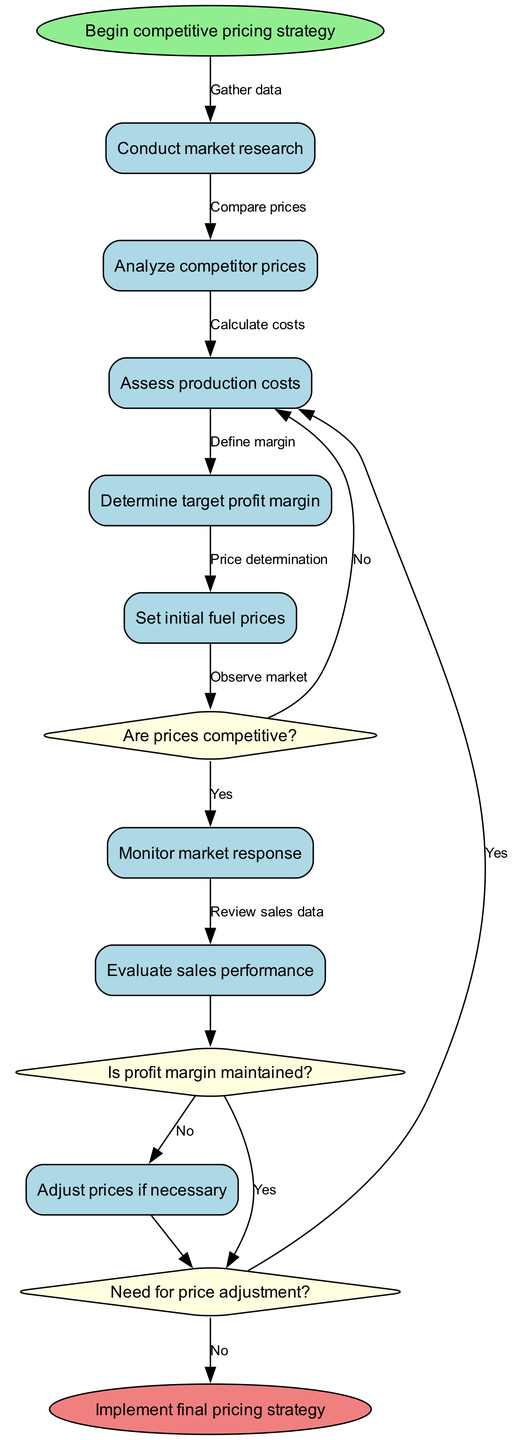What's the starting activity in this diagram? The diagram begins with the "Begin competitive pricing strategy" node, which is indicated as the start node.
Answer: Begin competitive pricing strategy How many activities are there in the diagram? The diagram lists a total of eight activities that describe the steps in implementing the pricing strategy.
Answer: Eight What is the first decision node in the diagram? The first decision node is "Are prices competitive?", which comes after setting the initial fuel prices.
Answer: Are prices competitive? Which activity follows the "Monitor market response" activity? The "Monitor market response" activity is followed by the decision node "Are prices competitive?", indicating a check after observing the market.
Answer: Are prices competitive? What happens if the profit margin is maintained according to the diagram? If the profit margin is maintained, the flow goes to the final decision node regarding price adjustment, indicating no changes in prices are needed.
Answer: Continue monitoring Describe the path taken if the prices are not competitive. If the prices are not competitive, the sequence would lead to re-assessing production costs and competitor prices, with the decision proceeding to examine if a price adjustment is needed.
Answer: Reassess strategy What decision follows evaluating sales performance? After evaluating sales performance, the decision to check if the profit margin is maintained is made, which influences the next steps in pricing strategy adjustments.
Answer: Is profit margin maintained? If adjustments are needed, what activity is performed next? If adjustments are deemed necessary, the next activity would involve making price changes according to the collected data and analysis.
Answer: Make price changes How does the diagram end? The diagram concludes with the "Implement final pricing strategy" node, which signifies the completion of the pricing strategy implementation.
Answer: Implement final pricing strategy 